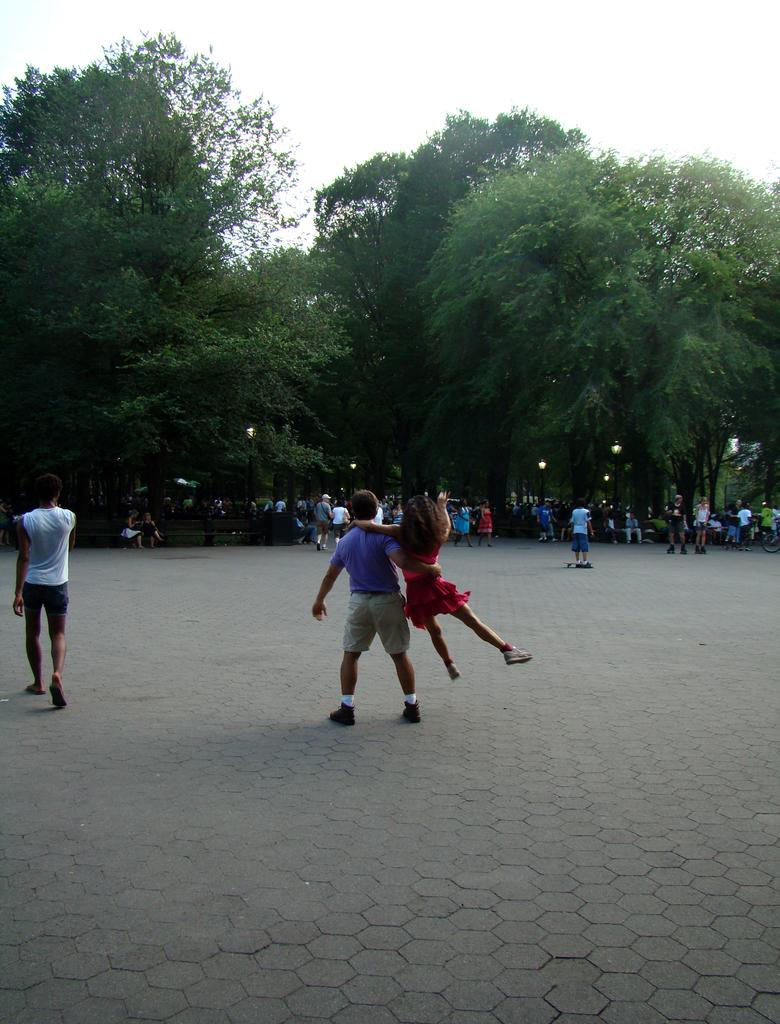What are the people in the image doing? The people in the image are standing and walking on a path. Can you describe the activity happening at the center of the image? A person is lifting a girl at the center of the image. What can be seen in the background of the image? There are trees and the sky visible in the background of the image. How many horses are present in the image? There are no horses present in the image. What type of business is being conducted in the image? There is no indication of any business activity in the image. 